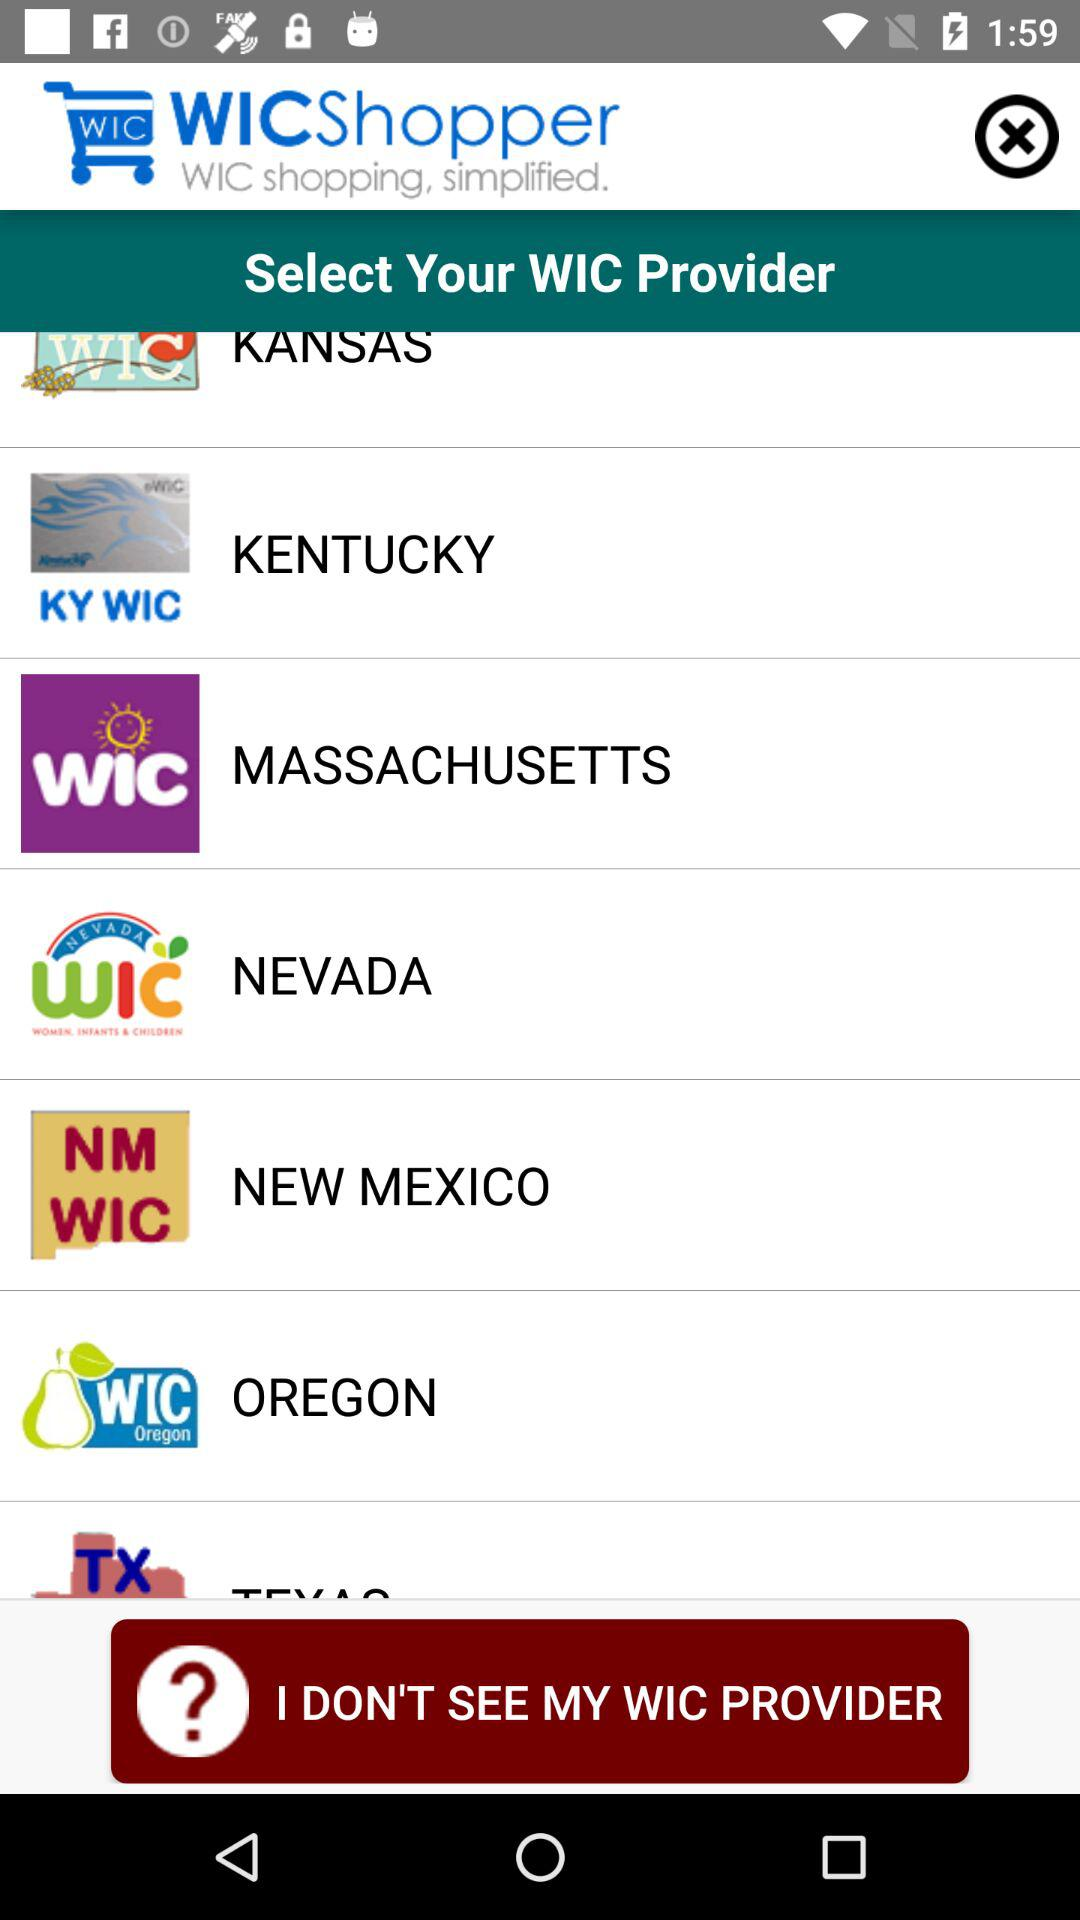What is the name of the application? The name of the application is "WICShopper". 